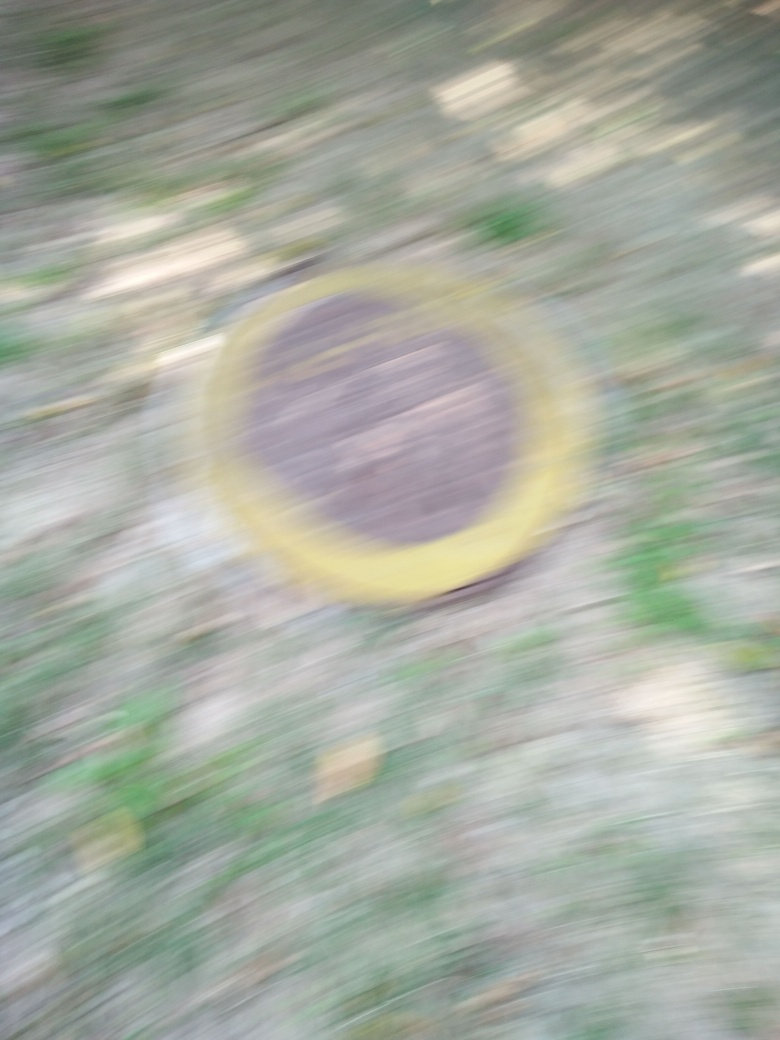What kind of settings might produce a better image of this object? To capture a clearer image of this object, one would ideally use a faster shutter speed to reduce motion blur, ensure the camera is stable, possibly by using a tripod, and employ a lower aperture if lighting conditions allow, to keep the subject in clear focus. 